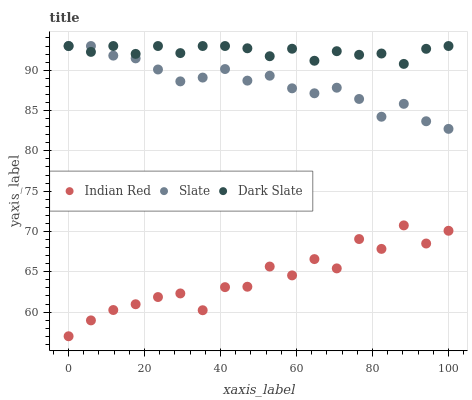Does Indian Red have the minimum area under the curve?
Answer yes or no. Yes. Does Dark Slate have the maximum area under the curve?
Answer yes or no. Yes. Does Slate have the minimum area under the curve?
Answer yes or no. No. Does Slate have the maximum area under the curve?
Answer yes or no. No. Is Dark Slate the smoothest?
Answer yes or no. Yes. Is Indian Red the roughest?
Answer yes or no. Yes. Is Slate the smoothest?
Answer yes or no. No. Is Slate the roughest?
Answer yes or no. No. Does Indian Red have the lowest value?
Answer yes or no. Yes. Does Slate have the lowest value?
Answer yes or no. No. Does Slate have the highest value?
Answer yes or no. Yes. Does Indian Red have the highest value?
Answer yes or no. No. Is Indian Red less than Slate?
Answer yes or no. Yes. Is Dark Slate greater than Indian Red?
Answer yes or no. Yes. Does Dark Slate intersect Slate?
Answer yes or no. Yes. Is Dark Slate less than Slate?
Answer yes or no. No. Is Dark Slate greater than Slate?
Answer yes or no. No. Does Indian Red intersect Slate?
Answer yes or no. No. 